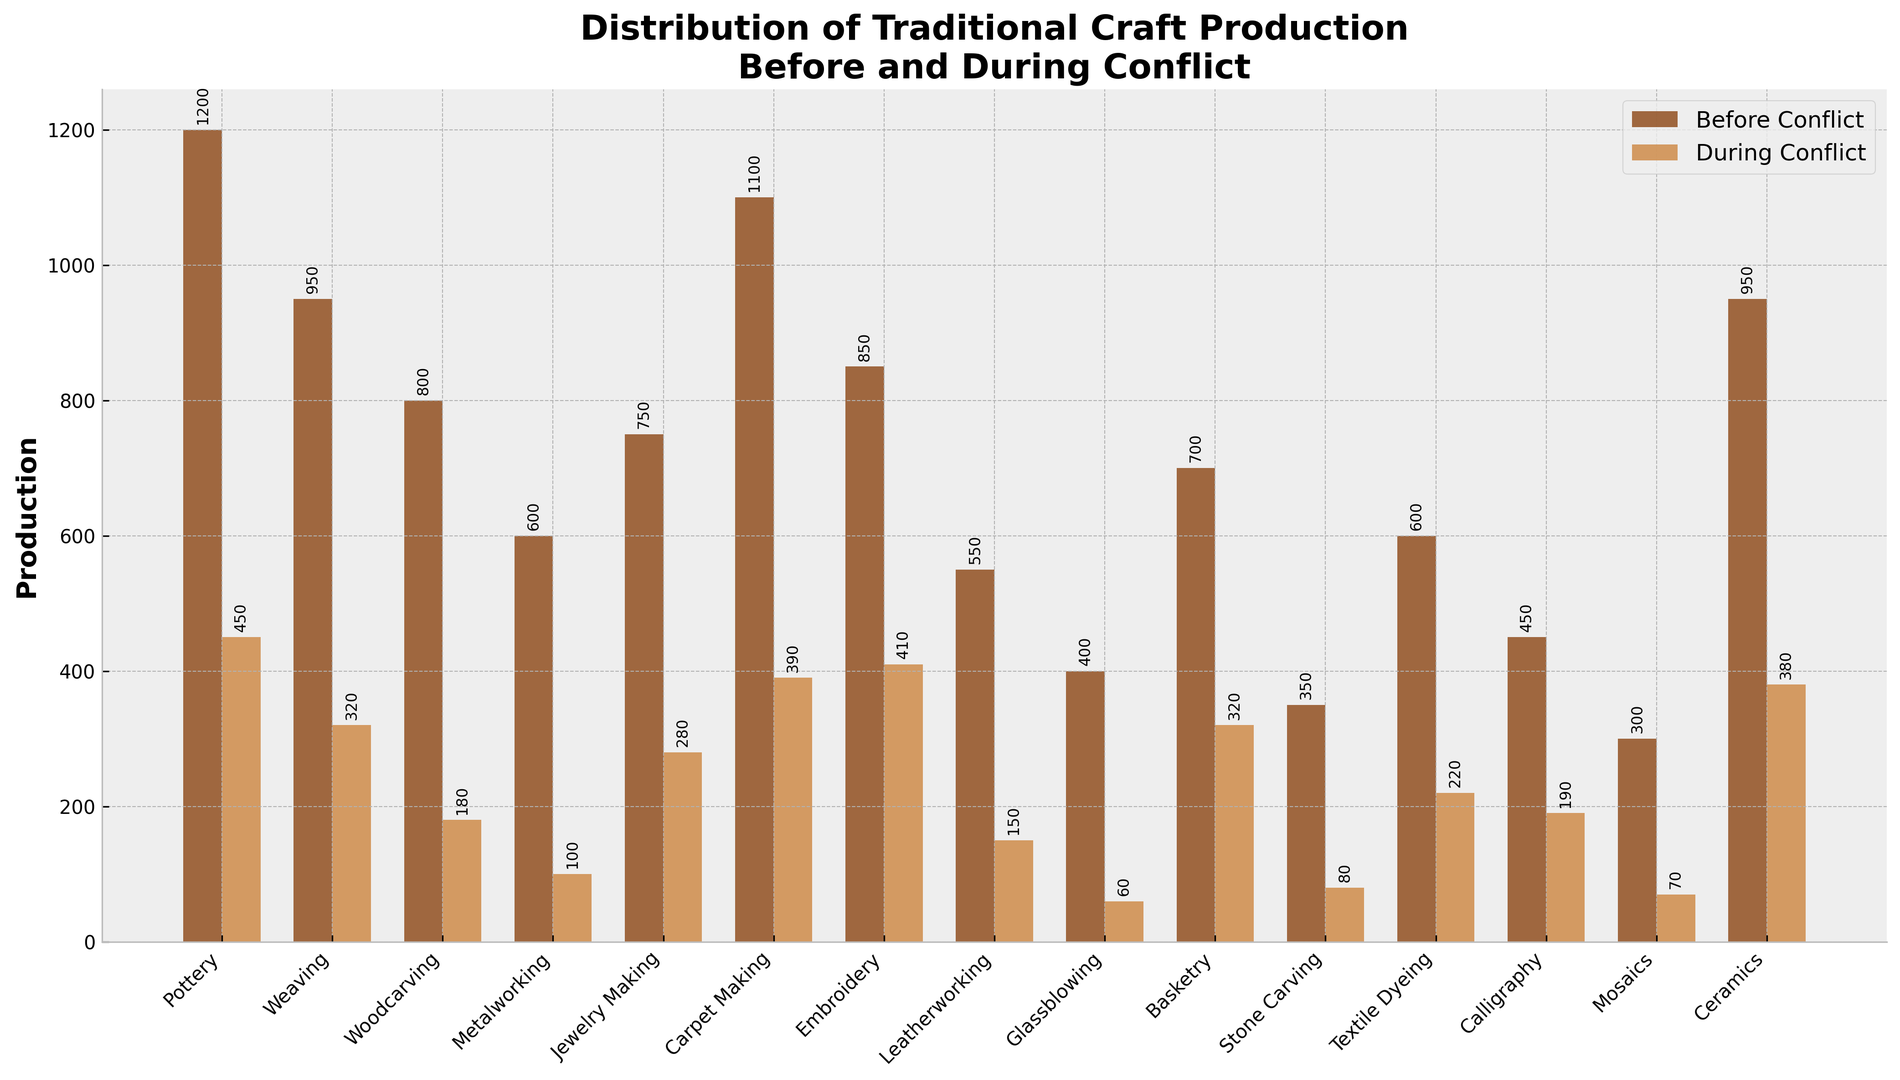How much did pottery production decrease during the conflict? The production of pottery before the conflict was 1200, and during the conflict, it is 450. The decrease is calculated as 1200 - 450.
Answer: 750 Which craft type had the smallest decline in production during the conflict? By inspecting the plotted bars, "Glassblowing" had the smallest decline, from 400 to 60.
Answer: Glassblowing Identify which craft type had the highest production before the conflict. By looking at the height of the bars marked "Before Conflict," "Pottery" had the highest production at 1200.
Answer: Pottery Compare the production of weaving and embroidery during the conflict. Which one had higher production? During the conflict, weaving produced 320, while embroidery produced 410. Embroidery had higher production.
Answer: Embroidery Sum up the production of stone carving and mosaics during the conflict. During the conflict, stone carving was 80, and mosaics were 70. Their total production is 80 + 70.
Answer: 150 Which activity saw a greater decrease in production, metalworking or leatherworking? Before the conflict, metalworking was 600, and during the conflict, it was 100. For leatherworking, it was 550 before and 150 during. The decrease for metalworking is 600 - 100 = 500, and for leatherworking, it's 550 - 150 = 400. Metalworking saw a greater decrease.
Answer: Metalworking Among all the craft types, which one has the least production during the conflict? From the chart, "Glassblowing" had the least production during the conflict, with only 60 units produced.
Answer: Glassblowing What is the average production of basketry before and during the conflict? Basketry production before the conflict was 700, and during the conflict it was 320. The average is (700 + 320) / 2.
Answer: 510 Compare the production drop of ceramics and textiles dyeing. Which one had a more significant percentage decline? Ceramics production dropped from 950 to 380, and textile dyeing dropped from 600 to 220. The percentage declines are calculated as (950-380)/950 * 100% for ceramics and (600-220)/600 * 100% for textile dyeing. Ceramics: (570/950)*100 = 60%. Textile dyeing: (380/600)*100 = 63.33%. Textile dyeing had a larger percentage decline.
Answer: Textile dyeing 